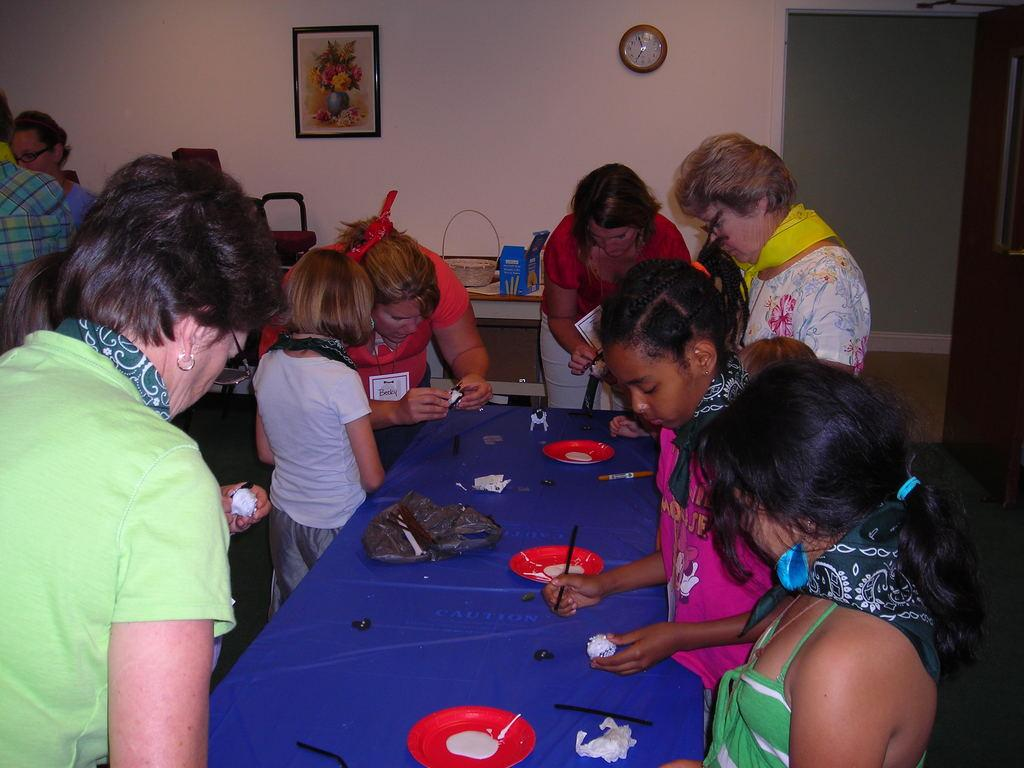What type of structure can be seen in the image? There is a wall in the image. What is hanging on the wall? There is a photo frame in the image. What time-telling device is present in the image? There is a clock in the image. Who or what is in front of the wall? There are people standing in the image. What piece of furniture is in the image? There is a table in the image. What is placed on the table? There is a plate on the table. Where is the branch located in the image? There is no branch present in the image. What type of desk is visible in the image? There is no desk present in the image. 